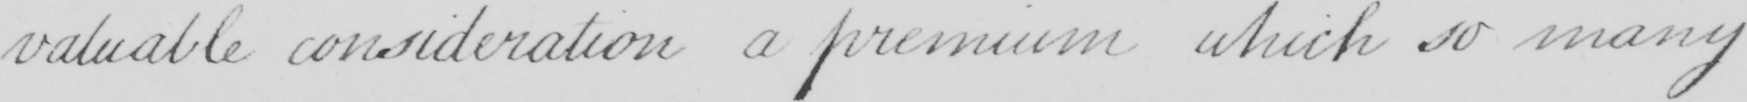What does this handwritten line say? valuable consideration a premium which so many 